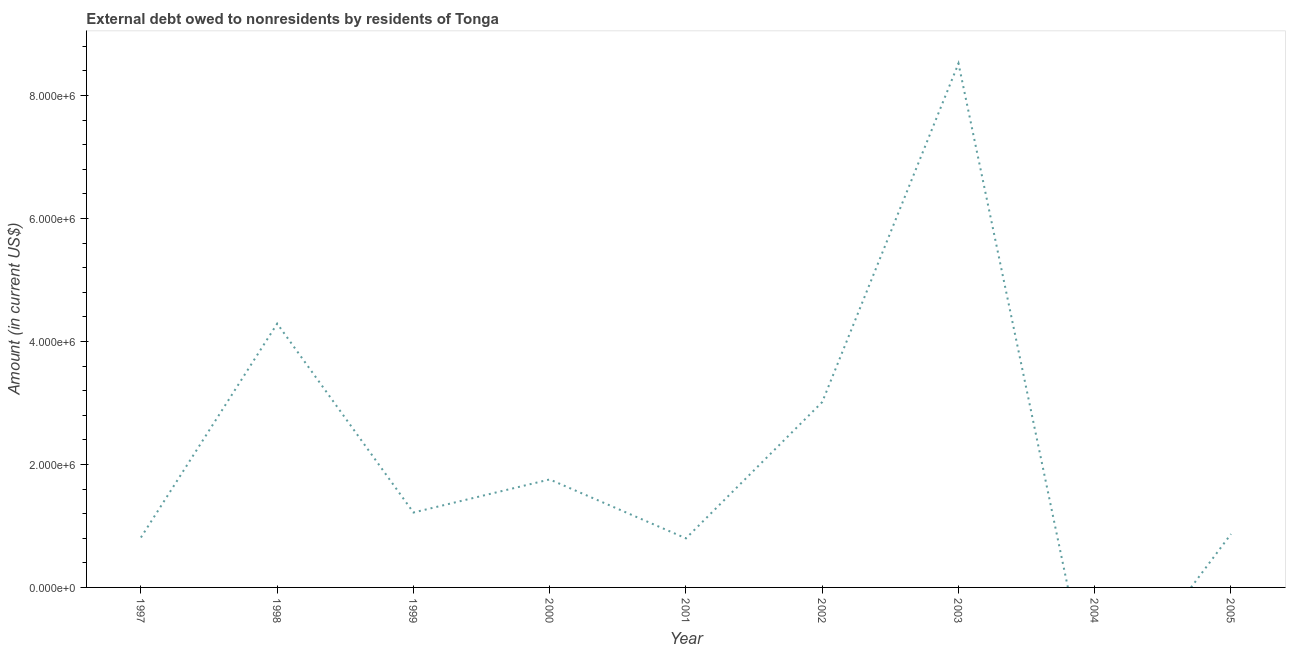What is the debt in 2003?
Ensure brevity in your answer.  8.52e+06. Across all years, what is the maximum debt?
Your answer should be compact. 8.52e+06. Across all years, what is the minimum debt?
Ensure brevity in your answer.  0. What is the sum of the debt?
Your response must be concise. 2.13e+07. What is the difference between the debt in 1999 and 2000?
Keep it short and to the point. -5.38e+05. What is the average debt per year?
Your answer should be very brief. 2.36e+06. What is the median debt?
Offer a terse response. 1.22e+06. In how many years, is the debt greater than 4000000 US$?
Ensure brevity in your answer.  2. What is the ratio of the debt in 2002 to that in 2005?
Give a very brief answer. 3.47. Is the difference between the debt in 1997 and 1999 greater than the difference between any two years?
Give a very brief answer. No. What is the difference between the highest and the second highest debt?
Provide a short and direct response. 4.23e+06. What is the difference between the highest and the lowest debt?
Give a very brief answer. 8.52e+06. How many years are there in the graph?
Provide a succinct answer. 9. Does the graph contain any zero values?
Your answer should be very brief. Yes. Does the graph contain grids?
Your response must be concise. No. What is the title of the graph?
Give a very brief answer. External debt owed to nonresidents by residents of Tonga. What is the label or title of the X-axis?
Offer a very short reply. Year. What is the Amount (in current US$) of 1997?
Provide a short and direct response. 8.12e+05. What is the Amount (in current US$) in 1998?
Your answer should be very brief. 4.29e+06. What is the Amount (in current US$) in 1999?
Your answer should be compact. 1.22e+06. What is the Amount (in current US$) of 2000?
Keep it short and to the point. 1.76e+06. What is the Amount (in current US$) of 2001?
Offer a terse response. 7.98e+05. What is the Amount (in current US$) in 2002?
Provide a succinct answer. 3.01e+06. What is the Amount (in current US$) of 2003?
Offer a terse response. 8.52e+06. What is the Amount (in current US$) of 2004?
Your answer should be compact. 0. What is the Amount (in current US$) in 2005?
Ensure brevity in your answer.  8.68e+05. What is the difference between the Amount (in current US$) in 1997 and 1998?
Provide a short and direct response. -3.48e+06. What is the difference between the Amount (in current US$) in 1997 and 1999?
Ensure brevity in your answer.  -4.06e+05. What is the difference between the Amount (in current US$) in 1997 and 2000?
Make the answer very short. -9.44e+05. What is the difference between the Amount (in current US$) in 1997 and 2001?
Offer a very short reply. 1.40e+04. What is the difference between the Amount (in current US$) in 1997 and 2002?
Ensure brevity in your answer.  -2.20e+06. What is the difference between the Amount (in current US$) in 1997 and 2003?
Offer a terse response. -7.71e+06. What is the difference between the Amount (in current US$) in 1997 and 2005?
Provide a succinct answer. -5.60e+04. What is the difference between the Amount (in current US$) in 1998 and 1999?
Make the answer very short. 3.07e+06. What is the difference between the Amount (in current US$) in 1998 and 2000?
Offer a very short reply. 2.53e+06. What is the difference between the Amount (in current US$) in 1998 and 2001?
Provide a succinct answer. 3.49e+06. What is the difference between the Amount (in current US$) in 1998 and 2002?
Offer a very short reply. 1.28e+06. What is the difference between the Amount (in current US$) in 1998 and 2003?
Your answer should be very brief. -4.23e+06. What is the difference between the Amount (in current US$) in 1998 and 2005?
Keep it short and to the point. 3.42e+06. What is the difference between the Amount (in current US$) in 1999 and 2000?
Make the answer very short. -5.38e+05. What is the difference between the Amount (in current US$) in 1999 and 2001?
Offer a terse response. 4.20e+05. What is the difference between the Amount (in current US$) in 1999 and 2002?
Your response must be concise. -1.80e+06. What is the difference between the Amount (in current US$) in 1999 and 2003?
Your answer should be compact. -7.30e+06. What is the difference between the Amount (in current US$) in 2000 and 2001?
Offer a very short reply. 9.58e+05. What is the difference between the Amount (in current US$) in 2000 and 2002?
Provide a succinct answer. -1.26e+06. What is the difference between the Amount (in current US$) in 2000 and 2003?
Make the answer very short. -6.76e+06. What is the difference between the Amount (in current US$) in 2000 and 2005?
Your answer should be compact. 8.88e+05. What is the difference between the Amount (in current US$) in 2001 and 2002?
Keep it short and to the point. -2.22e+06. What is the difference between the Amount (in current US$) in 2001 and 2003?
Give a very brief answer. -7.72e+06. What is the difference between the Amount (in current US$) in 2001 and 2005?
Provide a short and direct response. -7.00e+04. What is the difference between the Amount (in current US$) in 2002 and 2003?
Ensure brevity in your answer.  -5.51e+06. What is the difference between the Amount (in current US$) in 2002 and 2005?
Ensure brevity in your answer.  2.15e+06. What is the difference between the Amount (in current US$) in 2003 and 2005?
Keep it short and to the point. 7.65e+06. What is the ratio of the Amount (in current US$) in 1997 to that in 1998?
Your answer should be very brief. 0.19. What is the ratio of the Amount (in current US$) in 1997 to that in 1999?
Give a very brief answer. 0.67. What is the ratio of the Amount (in current US$) in 1997 to that in 2000?
Give a very brief answer. 0.46. What is the ratio of the Amount (in current US$) in 1997 to that in 2001?
Provide a short and direct response. 1.02. What is the ratio of the Amount (in current US$) in 1997 to that in 2002?
Provide a short and direct response. 0.27. What is the ratio of the Amount (in current US$) in 1997 to that in 2003?
Your answer should be compact. 0.1. What is the ratio of the Amount (in current US$) in 1997 to that in 2005?
Ensure brevity in your answer.  0.94. What is the ratio of the Amount (in current US$) in 1998 to that in 1999?
Ensure brevity in your answer.  3.52. What is the ratio of the Amount (in current US$) in 1998 to that in 2000?
Offer a very short reply. 2.44. What is the ratio of the Amount (in current US$) in 1998 to that in 2001?
Your answer should be compact. 5.38. What is the ratio of the Amount (in current US$) in 1998 to that in 2002?
Offer a very short reply. 1.42. What is the ratio of the Amount (in current US$) in 1998 to that in 2003?
Keep it short and to the point. 0.5. What is the ratio of the Amount (in current US$) in 1998 to that in 2005?
Offer a very short reply. 4.94. What is the ratio of the Amount (in current US$) in 1999 to that in 2000?
Your answer should be very brief. 0.69. What is the ratio of the Amount (in current US$) in 1999 to that in 2001?
Your answer should be compact. 1.53. What is the ratio of the Amount (in current US$) in 1999 to that in 2002?
Your answer should be compact. 0.4. What is the ratio of the Amount (in current US$) in 1999 to that in 2003?
Give a very brief answer. 0.14. What is the ratio of the Amount (in current US$) in 1999 to that in 2005?
Provide a succinct answer. 1.4. What is the ratio of the Amount (in current US$) in 2000 to that in 2001?
Your answer should be very brief. 2.2. What is the ratio of the Amount (in current US$) in 2000 to that in 2002?
Offer a very short reply. 0.58. What is the ratio of the Amount (in current US$) in 2000 to that in 2003?
Keep it short and to the point. 0.21. What is the ratio of the Amount (in current US$) in 2000 to that in 2005?
Ensure brevity in your answer.  2.02. What is the ratio of the Amount (in current US$) in 2001 to that in 2002?
Make the answer very short. 0.27. What is the ratio of the Amount (in current US$) in 2001 to that in 2003?
Your answer should be compact. 0.09. What is the ratio of the Amount (in current US$) in 2001 to that in 2005?
Your response must be concise. 0.92. What is the ratio of the Amount (in current US$) in 2002 to that in 2003?
Make the answer very short. 0.35. What is the ratio of the Amount (in current US$) in 2002 to that in 2005?
Provide a short and direct response. 3.47. What is the ratio of the Amount (in current US$) in 2003 to that in 2005?
Provide a succinct answer. 9.82. 